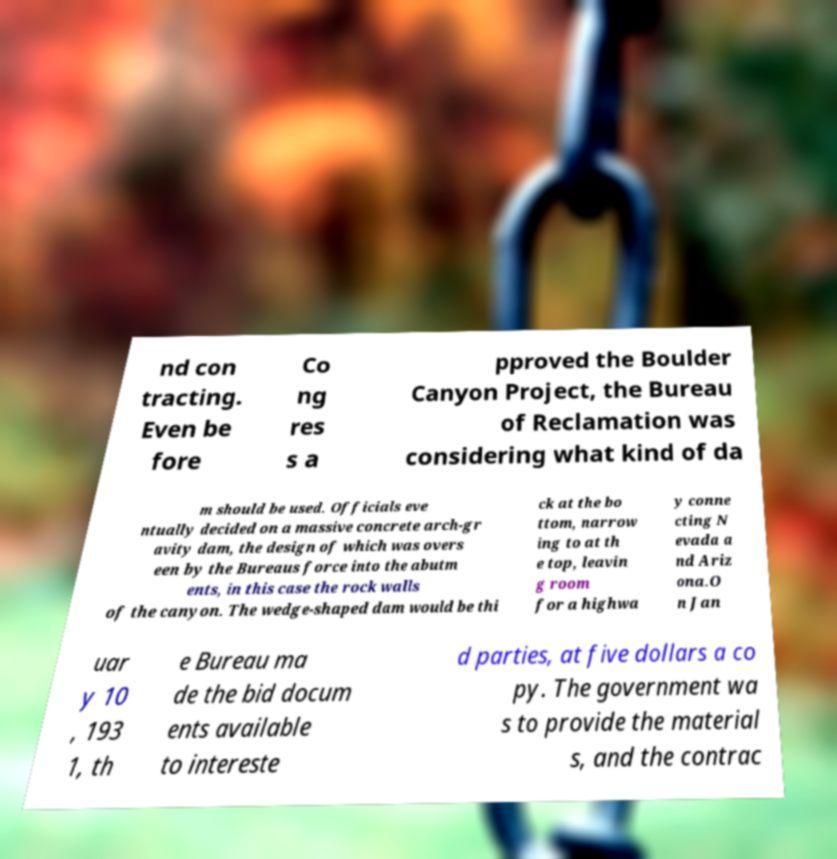Can you accurately transcribe the text from the provided image for me? nd con tracting. Even be fore Co ng res s a pproved the Boulder Canyon Project, the Bureau of Reclamation was considering what kind of da m should be used. Officials eve ntually decided on a massive concrete arch-gr avity dam, the design of which was overs een by the Bureaus force into the abutm ents, in this case the rock walls of the canyon. The wedge-shaped dam would be thi ck at the bo ttom, narrow ing to at th e top, leavin g room for a highwa y conne cting N evada a nd Ariz ona.O n Jan uar y 10 , 193 1, th e Bureau ma de the bid docum ents available to intereste d parties, at five dollars a co py. The government wa s to provide the material s, and the contrac 